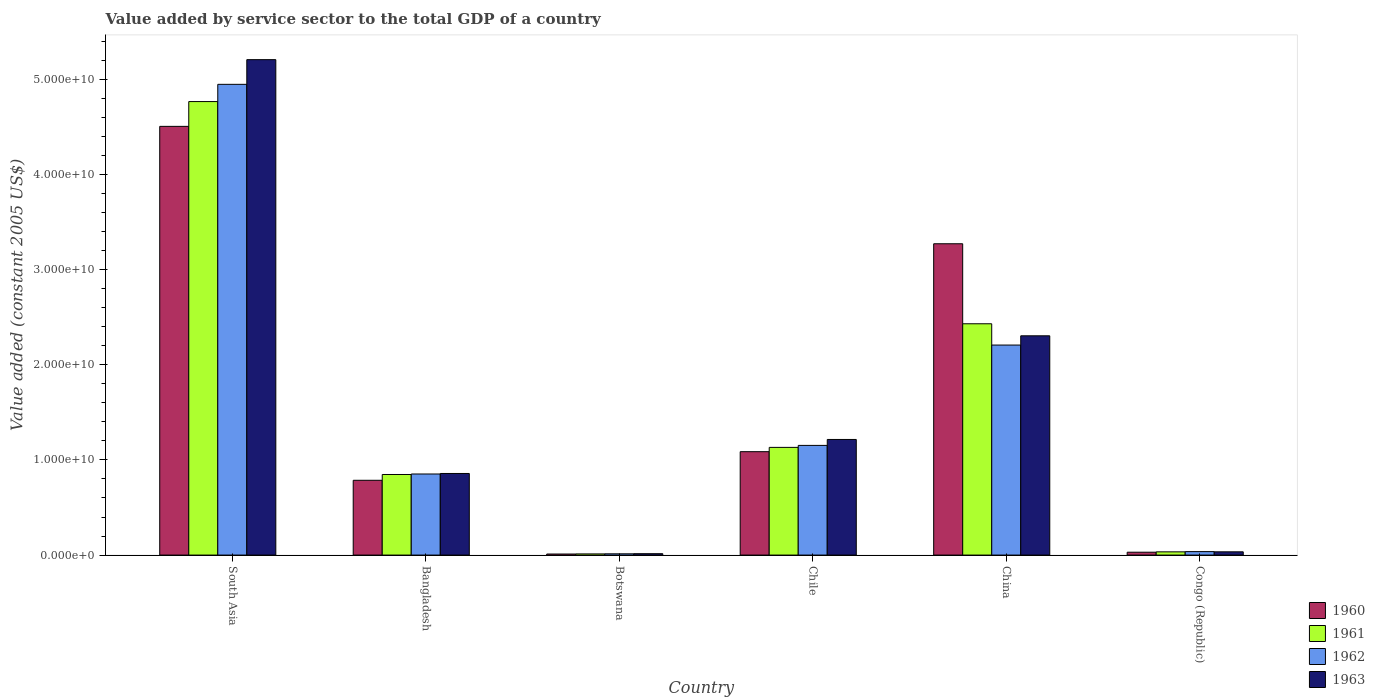How many different coloured bars are there?
Your answer should be compact. 4. How many groups of bars are there?
Offer a very short reply. 6. Are the number of bars per tick equal to the number of legend labels?
Your response must be concise. Yes. Are the number of bars on each tick of the X-axis equal?
Your response must be concise. Yes. How many bars are there on the 2nd tick from the left?
Provide a succinct answer. 4. How many bars are there on the 4th tick from the right?
Your response must be concise. 4. What is the label of the 5th group of bars from the left?
Your answer should be very brief. China. What is the value added by service sector in 1960 in Chile?
Make the answer very short. 1.09e+1. Across all countries, what is the maximum value added by service sector in 1960?
Give a very brief answer. 4.51e+1. Across all countries, what is the minimum value added by service sector in 1962?
Your answer should be compact. 1.32e+08. In which country was the value added by service sector in 1963 minimum?
Keep it short and to the point. Botswana. What is the total value added by service sector in 1961 in the graph?
Your answer should be very brief. 9.22e+1. What is the difference between the value added by service sector in 1961 in Bangladesh and that in Botswana?
Keep it short and to the point. 8.35e+09. What is the difference between the value added by service sector in 1960 in China and the value added by service sector in 1962 in Congo (Republic)?
Give a very brief answer. 3.24e+1. What is the average value added by service sector in 1963 per country?
Keep it short and to the point. 1.61e+1. What is the difference between the value added by service sector of/in 1961 and value added by service sector of/in 1963 in South Asia?
Your answer should be compact. -4.41e+09. What is the ratio of the value added by service sector in 1960 in Chile to that in China?
Your response must be concise. 0.33. Is the value added by service sector in 1961 in Botswana less than that in China?
Ensure brevity in your answer.  Yes. Is the difference between the value added by service sector in 1961 in Botswana and China greater than the difference between the value added by service sector in 1963 in Botswana and China?
Give a very brief answer. No. What is the difference between the highest and the second highest value added by service sector in 1961?
Offer a terse response. -3.63e+1. What is the difference between the highest and the lowest value added by service sector in 1960?
Your answer should be compact. 4.50e+1. In how many countries, is the value added by service sector in 1961 greater than the average value added by service sector in 1961 taken over all countries?
Provide a succinct answer. 2. What does the 2nd bar from the left in Congo (Republic) represents?
Provide a short and direct response. 1961. Is it the case that in every country, the sum of the value added by service sector in 1962 and value added by service sector in 1961 is greater than the value added by service sector in 1960?
Keep it short and to the point. Yes. How many countries are there in the graph?
Your answer should be compact. 6. Does the graph contain any zero values?
Give a very brief answer. No. How many legend labels are there?
Give a very brief answer. 4. How are the legend labels stacked?
Give a very brief answer. Vertical. What is the title of the graph?
Make the answer very short. Value added by service sector to the total GDP of a country. What is the label or title of the X-axis?
Provide a short and direct response. Country. What is the label or title of the Y-axis?
Ensure brevity in your answer.  Value added (constant 2005 US$). What is the Value added (constant 2005 US$) in 1960 in South Asia?
Ensure brevity in your answer.  4.51e+1. What is the Value added (constant 2005 US$) in 1961 in South Asia?
Provide a short and direct response. 4.77e+1. What is the Value added (constant 2005 US$) in 1962 in South Asia?
Keep it short and to the point. 4.95e+1. What is the Value added (constant 2005 US$) of 1963 in South Asia?
Your response must be concise. 5.21e+1. What is the Value added (constant 2005 US$) in 1960 in Bangladesh?
Give a very brief answer. 7.86e+09. What is the Value added (constant 2005 US$) in 1961 in Bangladesh?
Make the answer very short. 8.47e+09. What is the Value added (constant 2005 US$) of 1962 in Bangladesh?
Ensure brevity in your answer.  8.52e+09. What is the Value added (constant 2005 US$) of 1963 in Bangladesh?
Make the answer very short. 8.58e+09. What is the Value added (constant 2005 US$) in 1960 in Botswana?
Make the answer very short. 1.11e+08. What is the Value added (constant 2005 US$) of 1961 in Botswana?
Make the answer very short. 1.22e+08. What is the Value added (constant 2005 US$) of 1962 in Botswana?
Give a very brief answer. 1.32e+08. What is the Value added (constant 2005 US$) of 1963 in Botswana?
Provide a succinct answer. 1.45e+08. What is the Value added (constant 2005 US$) of 1960 in Chile?
Provide a short and direct response. 1.09e+1. What is the Value added (constant 2005 US$) in 1961 in Chile?
Your answer should be very brief. 1.13e+1. What is the Value added (constant 2005 US$) in 1962 in Chile?
Your answer should be very brief. 1.15e+1. What is the Value added (constant 2005 US$) in 1963 in Chile?
Offer a terse response. 1.22e+1. What is the Value added (constant 2005 US$) of 1960 in China?
Offer a very short reply. 3.27e+1. What is the Value added (constant 2005 US$) in 1961 in China?
Provide a succinct answer. 2.43e+1. What is the Value added (constant 2005 US$) in 1962 in China?
Offer a terse response. 2.21e+1. What is the Value added (constant 2005 US$) in 1963 in China?
Ensure brevity in your answer.  2.30e+1. What is the Value added (constant 2005 US$) in 1960 in Congo (Republic)?
Provide a succinct answer. 3.02e+08. What is the Value added (constant 2005 US$) in 1961 in Congo (Republic)?
Your answer should be very brief. 3.39e+08. What is the Value added (constant 2005 US$) of 1962 in Congo (Republic)?
Provide a short and direct response. 3.64e+08. What is the Value added (constant 2005 US$) in 1963 in Congo (Republic)?
Keep it short and to the point. 3.42e+08. Across all countries, what is the maximum Value added (constant 2005 US$) of 1960?
Offer a terse response. 4.51e+1. Across all countries, what is the maximum Value added (constant 2005 US$) of 1961?
Give a very brief answer. 4.77e+1. Across all countries, what is the maximum Value added (constant 2005 US$) of 1962?
Give a very brief answer. 4.95e+1. Across all countries, what is the maximum Value added (constant 2005 US$) in 1963?
Offer a very short reply. 5.21e+1. Across all countries, what is the minimum Value added (constant 2005 US$) in 1960?
Make the answer very short. 1.11e+08. Across all countries, what is the minimum Value added (constant 2005 US$) of 1961?
Make the answer very short. 1.22e+08. Across all countries, what is the minimum Value added (constant 2005 US$) in 1962?
Your response must be concise. 1.32e+08. Across all countries, what is the minimum Value added (constant 2005 US$) in 1963?
Provide a short and direct response. 1.45e+08. What is the total Value added (constant 2005 US$) of 1960 in the graph?
Your answer should be compact. 9.69e+1. What is the total Value added (constant 2005 US$) in 1961 in the graph?
Make the answer very short. 9.22e+1. What is the total Value added (constant 2005 US$) of 1962 in the graph?
Ensure brevity in your answer.  9.21e+1. What is the total Value added (constant 2005 US$) of 1963 in the graph?
Provide a succinct answer. 9.63e+1. What is the difference between the Value added (constant 2005 US$) in 1960 in South Asia and that in Bangladesh?
Your answer should be very brief. 3.72e+1. What is the difference between the Value added (constant 2005 US$) of 1961 in South Asia and that in Bangladesh?
Give a very brief answer. 3.92e+1. What is the difference between the Value added (constant 2005 US$) of 1962 in South Asia and that in Bangladesh?
Your response must be concise. 4.10e+1. What is the difference between the Value added (constant 2005 US$) of 1963 in South Asia and that in Bangladesh?
Your answer should be very brief. 4.35e+1. What is the difference between the Value added (constant 2005 US$) in 1960 in South Asia and that in Botswana?
Give a very brief answer. 4.50e+1. What is the difference between the Value added (constant 2005 US$) in 1961 in South Asia and that in Botswana?
Your response must be concise. 4.75e+1. What is the difference between the Value added (constant 2005 US$) in 1962 in South Asia and that in Botswana?
Your answer should be very brief. 4.93e+1. What is the difference between the Value added (constant 2005 US$) of 1963 in South Asia and that in Botswana?
Provide a short and direct response. 5.19e+1. What is the difference between the Value added (constant 2005 US$) of 1960 in South Asia and that in Chile?
Offer a very short reply. 3.42e+1. What is the difference between the Value added (constant 2005 US$) in 1961 in South Asia and that in Chile?
Provide a succinct answer. 3.63e+1. What is the difference between the Value added (constant 2005 US$) in 1962 in South Asia and that in Chile?
Your answer should be very brief. 3.80e+1. What is the difference between the Value added (constant 2005 US$) of 1963 in South Asia and that in Chile?
Give a very brief answer. 3.99e+1. What is the difference between the Value added (constant 2005 US$) in 1960 in South Asia and that in China?
Offer a terse response. 1.23e+1. What is the difference between the Value added (constant 2005 US$) of 1961 in South Asia and that in China?
Keep it short and to the point. 2.34e+1. What is the difference between the Value added (constant 2005 US$) of 1962 in South Asia and that in China?
Offer a very short reply. 2.74e+1. What is the difference between the Value added (constant 2005 US$) of 1963 in South Asia and that in China?
Provide a succinct answer. 2.90e+1. What is the difference between the Value added (constant 2005 US$) of 1960 in South Asia and that in Congo (Republic)?
Your answer should be very brief. 4.48e+1. What is the difference between the Value added (constant 2005 US$) in 1961 in South Asia and that in Congo (Republic)?
Your answer should be very brief. 4.73e+1. What is the difference between the Value added (constant 2005 US$) in 1962 in South Asia and that in Congo (Republic)?
Keep it short and to the point. 4.91e+1. What is the difference between the Value added (constant 2005 US$) in 1963 in South Asia and that in Congo (Republic)?
Offer a terse response. 5.17e+1. What is the difference between the Value added (constant 2005 US$) in 1960 in Bangladesh and that in Botswana?
Provide a short and direct response. 7.75e+09. What is the difference between the Value added (constant 2005 US$) in 1961 in Bangladesh and that in Botswana?
Provide a succinct answer. 8.35e+09. What is the difference between the Value added (constant 2005 US$) in 1962 in Bangladesh and that in Botswana?
Provide a short and direct response. 8.39e+09. What is the difference between the Value added (constant 2005 US$) in 1963 in Bangladesh and that in Botswana?
Give a very brief answer. 8.43e+09. What is the difference between the Value added (constant 2005 US$) of 1960 in Bangladesh and that in Chile?
Ensure brevity in your answer.  -3.01e+09. What is the difference between the Value added (constant 2005 US$) in 1961 in Bangladesh and that in Chile?
Provide a short and direct response. -2.85e+09. What is the difference between the Value added (constant 2005 US$) of 1962 in Bangladesh and that in Chile?
Make the answer very short. -3.00e+09. What is the difference between the Value added (constant 2005 US$) in 1963 in Bangladesh and that in Chile?
Your answer should be very brief. -3.58e+09. What is the difference between the Value added (constant 2005 US$) of 1960 in Bangladesh and that in China?
Your answer should be very brief. -2.49e+1. What is the difference between the Value added (constant 2005 US$) in 1961 in Bangladesh and that in China?
Give a very brief answer. -1.58e+1. What is the difference between the Value added (constant 2005 US$) in 1962 in Bangladesh and that in China?
Your response must be concise. -1.36e+1. What is the difference between the Value added (constant 2005 US$) in 1963 in Bangladesh and that in China?
Offer a very short reply. -1.45e+1. What is the difference between the Value added (constant 2005 US$) in 1960 in Bangladesh and that in Congo (Republic)?
Your answer should be very brief. 7.56e+09. What is the difference between the Value added (constant 2005 US$) of 1961 in Bangladesh and that in Congo (Republic)?
Provide a succinct answer. 8.13e+09. What is the difference between the Value added (constant 2005 US$) in 1962 in Bangladesh and that in Congo (Republic)?
Give a very brief answer. 8.16e+09. What is the difference between the Value added (constant 2005 US$) of 1963 in Bangladesh and that in Congo (Republic)?
Your answer should be very brief. 8.24e+09. What is the difference between the Value added (constant 2005 US$) of 1960 in Botswana and that in Chile?
Give a very brief answer. -1.08e+1. What is the difference between the Value added (constant 2005 US$) of 1961 in Botswana and that in Chile?
Keep it short and to the point. -1.12e+1. What is the difference between the Value added (constant 2005 US$) in 1962 in Botswana and that in Chile?
Provide a succinct answer. -1.14e+1. What is the difference between the Value added (constant 2005 US$) in 1963 in Botswana and that in Chile?
Keep it short and to the point. -1.20e+1. What is the difference between the Value added (constant 2005 US$) of 1960 in Botswana and that in China?
Offer a very short reply. -3.26e+1. What is the difference between the Value added (constant 2005 US$) in 1961 in Botswana and that in China?
Your answer should be very brief. -2.42e+1. What is the difference between the Value added (constant 2005 US$) of 1962 in Botswana and that in China?
Your response must be concise. -2.19e+1. What is the difference between the Value added (constant 2005 US$) in 1963 in Botswana and that in China?
Your answer should be compact. -2.29e+1. What is the difference between the Value added (constant 2005 US$) in 1960 in Botswana and that in Congo (Republic)?
Offer a terse response. -1.91e+08. What is the difference between the Value added (constant 2005 US$) of 1961 in Botswana and that in Congo (Republic)?
Offer a very short reply. -2.17e+08. What is the difference between the Value added (constant 2005 US$) of 1962 in Botswana and that in Congo (Republic)?
Ensure brevity in your answer.  -2.32e+08. What is the difference between the Value added (constant 2005 US$) of 1963 in Botswana and that in Congo (Republic)?
Make the answer very short. -1.97e+08. What is the difference between the Value added (constant 2005 US$) of 1960 in Chile and that in China?
Offer a terse response. -2.19e+1. What is the difference between the Value added (constant 2005 US$) of 1961 in Chile and that in China?
Offer a very short reply. -1.30e+1. What is the difference between the Value added (constant 2005 US$) of 1962 in Chile and that in China?
Provide a succinct answer. -1.05e+1. What is the difference between the Value added (constant 2005 US$) in 1963 in Chile and that in China?
Your answer should be very brief. -1.09e+1. What is the difference between the Value added (constant 2005 US$) in 1960 in Chile and that in Congo (Republic)?
Provide a succinct answer. 1.06e+1. What is the difference between the Value added (constant 2005 US$) in 1961 in Chile and that in Congo (Republic)?
Offer a terse response. 1.10e+1. What is the difference between the Value added (constant 2005 US$) in 1962 in Chile and that in Congo (Republic)?
Make the answer very short. 1.12e+1. What is the difference between the Value added (constant 2005 US$) of 1963 in Chile and that in Congo (Republic)?
Keep it short and to the point. 1.18e+1. What is the difference between the Value added (constant 2005 US$) in 1960 in China and that in Congo (Republic)?
Your answer should be very brief. 3.24e+1. What is the difference between the Value added (constant 2005 US$) in 1961 in China and that in Congo (Republic)?
Offer a terse response. 2.40e+1. What is the difference between the Value added (constant 2005 US$) of 1962 in China and that in Congo (Republic)?
Offer a very short reply. 2.17e+1. What is the difference between the Value added (constant 2005 US$) in 1963 in China and that in Congo (Republic)?
Keep it short and to the point. 2.27e+1. What is the difference between the Value added (constant 2005 US$) of 1960 in South Asia and the Value added (constant 2005 US$) of 1961 in Bangladesh?
Your answer should be compact. 3.66e+1. What is the difference between the Value added (constant 2005 US$) of 1960 in South Asia and the Value added (constant 2005 US$) of 1962 in Bangladesh?
Keep it short and to the point. 3.65e+1. What is the difference between the Value added (constant 2005 US$) in 1960 in South Asia and the Value added (constant 2005 US$) in 1963 in Bangladesh?
Your response must be concise. 3.65e+1. What is the difference between the Value added (constant 2005 US$) in 1961 in South Asia and the Value added (constant 2005 US$) in 1962 in Bangladesh?
Offer a terse response. 3.91e+1. What is the difference between the Value added (constant 2005 US$) in 1961 in South Asia and the Value added (constant 2005 US$) in 1963 in Bangladesh?
Your response must be concise. 3.91e+1. What is the difference between the Value added (constant 2005 US$) in 1962 in South Asia and the Value added (constant 2005 US$) in 1963 in Bangladesh?
Make the answer very short. 4.09e+1. What is the difference between the Value added (constant 2005 US$) of 1960 in South Asia and the Value added (constant 2005 US$) of 1961 in Botswana?
Provide a succinct answer. 4.49e+1. What is the difference between the Value added (constant 2005 US$) in 1960 in South Asia and the Value added (constant 2005 US$) in 1962 in Botswana?
Provide a succinct answer. 4.49e+1. What is the difference between the Value added (constant 2005 US$) of 1960 in South Asia and the Value added (constant 2005 US$) of 1963 in Botswana?
Provide a short and direct response. 4.49e+1. What is the difference between the Value added (constant 2005 US$) of 1961 in South Asia and the Value added (constant 2005 US$) of 1962 in Botswana?
Offer a terse response. 4.75e+1. What is the difference between the Value added (constant 2005 US$) in 1961 in South Asia and the Value added (constant 2005 US$) in 1963 in Botswana?
Offer a terse response. 4.75e+1. What is the difference between the Value added (constant 2005 US$) of 1962 in South Asia and the Value added (constant 2005 US$) of 1963 in Botswana?
Provide a succinct answer. 4.93e+1. What is the difference between the Value added (constant 2005 US$) of 1960 in South Asia and the Value added (constant 2005 US$) of 1961 in Chile?
Ensure brevity in your answer.  3.37e+1. What is the difference between the Value added (constant 2005 US$) of 1960 in South Asia and the Value added (constant 2005 US$) of 1962 in Chile?
Make the answer very short. 3.35e+1. What is the difference between the Value added (constant 2005 US$) of 1960 in South Asia and the Value added (constant 2005 US$) of 1963 in Chile?
Your answer should be compact. 3.29e+1. What is the difference between the Value added (constant 2005 US$) of 1961 in South Asia and the Value added (constant 2005 US$) of 1962 in Chile?
Make the answer very short. 3.61e+1. What is the difference between the Value added (constant 2005 US$) in 1961 in South Asia and the Value added (constant 2005 US$) in 1963 in Chile?
Keep it short and to the point. 3.55e+1. What is the difference between the Value added (constant 2005 US$) of 1962 in South Asia and the Value added (constant 2005 US$) of 1963 in Chile?
Ensure brevity in your answer.  3.73e+1. What is the difference between the Value added (constant 2005 US$) in 1960 in South Asia and the Value added (constant 2005 US$) in 1961 in China?
Keep it short and to the point. 2.08e+1. What is the difference between the Value added (constant 2005 US$) in 1960 in South Asia and the Value added (constant 2005 US$) in 1962 in China?
Your answer should be very brief. 2.30e+1. What is the difference between the Value added (constant 2005 US$) of 1960 in South Asia and the Value added (constant 2005 US$) of 1963 in China?
Keep it short and to the point. 2.20e+1. What is the difference between the Value added (constant 2005 US$) in 1961 in South Asia and the Value added (constant 2005 US$) in 1962 in China?
Make the answer very short. 2.56e+1. What is the difference between the Value added (constant 2005 US$) of 1961 in South Asia and the Value added (constant 2005 US$) of 1963 in China?
Your response must be concise. 2.46e+1. What is the difference between the Value added (constant 2005 US$) in 1962 in South Asia and the Value added (constant 2005 US$) in 1963 in China?
Offer a terse response. 2.64e+1. What is the difference between the Value added (constant 2005 US$) of 1960 in South Asia and the Value added (constant 2005 US$) of 1961 in Congo (Republic)?
Keep it short and to the point. 4.47e+1. What is the difference between the Value added (constant 2005 US$) in 1960 in South Asia and the Value added (constant 2005 US$) in 1962 in Congo (Republic)?
Your answer should be very brief. 4.47e+1. What is the difference between the Value added (constant 2005 US$) of 1960 in South Asia and the Value added (constant 2005 US$) of 1963 in Congo (Republic)?
Give a very brief answer. 4.47e+1. What is the difference between the Value added (constant 2005 US$) of 1961 in South Asia and the Value added (constant 2005 US$) of 1962 in Congo (Republic)?
Provide a short and direct response. 4.73e+1. What is the difference between the Value added (constant 2005 US$) of 1961 in South Asia and the Value added (constant 2005 US$) of 1963 in Congo (Republic)?
Your answer should be very brief. 4.73e+1. What is the difference between the Value added (constant 2005 US$) in 1962 in South Asia and the Value added (constant 2005 US$) in 1963 in Congo (Republic)?
Make the answer very short. 4.91e+1. What is the difference between the Value added (constant 2005 US$) of 1960 in Bangladesh and the Value added (constant 2005 US$) of 1961 in Botswana?
Ensure brevity in your answer.  7.74e+09. What is the difference between the Value added (constant 2005 US$) of 1960 in Bangladesh and the Value added (constant 2005 US$) of 1962 in Botswana?
Your answer should be compact. 7.73e+09. What is the difference between the Value added (constant 2005 US$) of 1960 in Bangladesh and the Value added (constant 2005 US$) of 1963 in Botswana?
Offer a very short reply. 7.72e+09. What is the difference between the Value added (constant 2005 US$) of 1961 in Bangladesh and the Value added (constant 2005 US$) of 1962 in Botswana?
Give a very brief answer. 8.34e+09. What is the difference between the Value added (constant 2005 US$) of 1961 in Bangladesh and the Value added (constant 2005 US$) of 1963 in Botswana?
Keep it short and to the point. 8.32e+09. What is the difference between the Value added (constant 2005 US$) in 1962 in Bangladesh and the Value added (constant 2005 US$) in 1963 in Botswana?
Ensure brevity in your answer.  8.38e+09. What is the difference between the Value added (constant 2005 US$) in 1960 in Bangladesh and the Value added (constant 2005 US$) in 1961 in Chile?
Provide a short and direct response. -3.46e+09. What is the difference between the Value added (constant 2005 US$) of 1960 in Bangladesh and the Value added (constant 2005 US$) of 1962 in Chile?
Keep it short and to the point. -3.67e+09. What is the difference between the Value added (constant 2005 US$) in 1960 in Bangladesh and the Value added (constant 2005 US$) in 1963 in Chile?
Give a very brief answer. -4.29e+09. What is the difference between the Value added (constant 2005 US$) in 1961 in Bangladesh and the Value added (constant 2005 US$) in 1962 in Chile?
Your answer should be very brief. -3.06e+09. What is the difference between the Value added (constant 2005 US$) of 1961 in Bangladesh and the Value added (constant 2005 US$) of 1963 in Chile?
Give a very brief answer. -3.68e+09. What is the difference between the Value added (constant 2005 US$) in 1962 in Bangladesh and the Value added (constant 2005 US$) in 1963 in Chile?
Offer a very short reply. -3.63e+09. What is the difference between the Value added (constant 2005 US$) of 1960 in Bangladesh and the Value added (constant 2005 US$) of 1961 in China?
Ensure brevity in your answer.  -1.65e+1. What is the difference between the Value added (constant 2005 US$) of 1960 in Bangladesh and the Value added (constant 2005 US$) of 1962 in China?
Give a very brief answer. -1.42e+1. What is the difference between the Value added (constant 2005 US$) of 1960 in Bangladesh and the Value added (constant 2005 US$) of 1963 in China?
Offer a very short reply. -1.52e+1. What is the difference between the Value added (constant 2005 US$) of 1961 in Bangladesh and the Value added (constant 2005 US$) of 1962 in China?
Ensure brevity in your answer.  -1.36e+1. What is the difference between the Value added (constant 2005 US$) of 1961 in Bangladesh and the Value added (constant 2005 US$) of 1963 in China?
Your response must be concise. -1.46e+1. What is the difference between the Value added (constant 2005 US$) of 1962 in Bangladesh and the Value added (constant 2005 US$) of 1963 in China?
Your answer should be compact. -1.45e+1. What is the difference between the Value added (constant 2005 US$) in 1960 in Bangladesh and the Value added (constant 2005 US$) in 1961 in Congo (Republic)?
Your response must be concise. 7.52e+09. What is the difference between the Value added (constant 2005 US$) of 1960 in Bangladesh and the Value added (constant 2005 US$) of 1962 in Congo (Republic)?
Offer a very short reply. 7.50e+09. What is the difference between the Value added (constant 2005 US$) of 1960 in Bangladesh and the Value added (constant 2005 US$) of 1963 in Congo (Republic)?
Your answer should be very brief. 7.52e+09. What is the difference between the Value added (constant 2005 US$) of 1961 in Bangladesh and the Value added (constant 2005 US$) of 1962 in Congo (Republic)?
Keep it short and to the point. 8.11e+09. What is the difference between the Value added (constant 2005 US$) of 1961 in Bangladesh and the Value added (constant 2005 US$) of 1963 in Congo (Republic)?
Your response must be concise. 8.13e+09. What is the difference between the Value added (constant 2005 US$) in 1962 in Bangladesh and the Value added (constant 2005 US$) in 1963 in Congo (Republic)?
Make the answer very short. 8.18e+09. What is the difference between the Value added (constant 2005 US$) of 1960 in Botswana and the Value added (constant 2005 US$) of 1961 in Chile?
Offer a terse response. -1.12e+1. What is the difference between the Value added (constant 2005 US$) in 1960 in Botswana and the Value added (constant 2005 US$) in 1962 in Chile?
Provide a succinct answer. -1.14e+1. What is the difference between the Value added (constant 2005 US$) in 1960 in Botswana and the Value added (constant 2005 US$) in 1963 in Chile?
Keep it short and to the point. -1.20e+1. What is the difference between the Value added (constant 2005 US$) in 1961 in Botswana and the Value added (constant 2005 US$) in 1962 in Chile?
Offer a very short reply. -1.14e+1. What is the difference between the Value added (constant 2005 US$) of 1961 in Botswana and the Value added (constant 2005 US$) of 1963 in Chile?
Offer a terse response. -1.20e+1. What is the difference between the Value added (constant 2005 US$) in 1962 in Botswana and the Value added (constant 2005 US$) in 1963 in Chile?
Provide a short and direct response. -1.20e+1. What is the difference between the Value added (constant 2005 US$) of 1960 in Botswana and the Value added (constant 2005 US$) of 1961 in China?
Your answer should be compact. -2.42e+1. What is the difference between the Value added (constant 2005 US$) in 1960 in Botswana and the Value added (constant 2005 US$) in 1962 in China?
Offer a terse response. -2.20e+1. What is the difference between the Value added (constant 2005 US$) in 1960 in Botswana and the Value added (constant 2005 US$) in 1963 in China?
Offer a terse response. -2.29e+1. What is the difference between the Value added (constant 2005 US$) in 1961 in Botswana and the Value added (constant 2005 US$) in 1962 in China?
Give a very brief answer. -2.20e+1. What is the difference between the Value added (constant 2005 US$) of 1961 in Botswana and the Value added (constant 2005 US$) of 1963 in China?
Give a very brief answer. -2.29e+1. What is the difference between the Value added (constant 2005 US$) of 1962 in Botswana and the Value added (constant 2005 US$) of 1963 in China?
Provide a succinct answer. -2.29e+1. What is the difference between the Value added (constant 2005 US$) in 1960 in Botswana and the Value added (constant 2005 US$) in 1961 in Congo (Republic)?
Offer a very short reply. -2.28e+08. What is the difference between the Value added (constant 2005 US$) in 1960 in Botswana and the Value added (constant 2005 US$) in 1962 in Congo (Republic)?
Offer a terse response. -2.53e+08. What is the difference between the Value added (constant 2005 US$) of 1960 in Botswana and the Value added (constant 2005 US$) of 1963 in Congo (Republic)?
Provide a short and direct response. -2.31e+08. What is the difference between the Value added (constant 2005 US$) in 1961 in Botswana and the Value added (constant 2005 US$) in 1962 in Congo (Republic)?
Your answer should be very brief. -2.42e+08. What is the difference between the Value added (constant 2005 US$) in 1961 in Botswana and the Value added (constant 2005 US$) in 1963 in Congo (Republic)?
Give a very brief answer. -2.20e+08. What is the difference between the Value added (constant 2005 US$) in 1962 in Botswana and the Value added (constant 2005 US$) in 1963 in Congo (Republic)?
Your response must be concise. -2.10e+08. What is the difference between the Value added (constant 2005 US$) of 1960 in Chile and the Value added (constant 2005 US$) of 1961 in China?
Your answer should be very brief. -1.34e+1. What is the difference between the Value added (constant 2005 US$) of 1960 in Chile and the Value added (constant 2005 US$) of 1962 in China?
Provide a succinct answer. -1.12e+1. What is the difference between the Value added (constant 2005 US$) in 1960 in Chile and the Value added (constant 2005 US$) in 1963 in China?
Your answer should be compact. -1.22e+1. What is the difference between the Value added (constant 2005 US$) of 1961 in Chile and the Value added (constant 2005 US$) of 1962 in China?
Offer a terse response. -1.08e+1. What is the difference between the Value added (constant 2005 US$) of 1961 in Chile and the Value added (constant 2005 US$) of 1963 in China?
Provide a succinct answer. -1.17e+1. What is the difference between the Value added (constant 2005 US$) of 1962 in Chile and the Value added (constant 2005 US$) of 1963 in China?
Give a very brief answer. -1.15e+1. What is the difference between the Value added (constant 2005 US$) of 1960 in Chile and the Value added (constant 2005 US$) of 1961 in Congo (Republic)?
Give a very brief answer. 1.05e+1. What is the difference between the Value added (constant 2005 US$) in 1960 in Chile and the Value added (constant 2005 US$) in 1962 in Congo (Republic)?
Provide a succinct answer. 1.05e+1. What is the difference between the Value added (constant 2005 US$) in 1960 in Chile and the Value added (constant 2005 US$) in 1963 in Congo (Republic)?
Make the answer very short. 1.05e+1. What is the difference between the Value added (constant 2005 US$) of 1961 in Chile and the Value added (constant 2005 US$) of 1962 in Congo (Republic)?
Your answer should be very brief. 1.10e+1. What is the difference between the Value added (constant 2005 US$) in 1961 in Chile and the Value added (constant 2005 US$) in 1963 in Congo (Republic)?
Offer a terse response. 1.10e+1. What is the difference between the Value added (constant 2005 US$) in 1962 in Chile and the Value added (constant 2005 US$) in 1963 in Congo (Republic)?
Provide a short and direct response. 1.12e+1. What is the difference between the Value added (constant 2005 US$) in 1960 in China and the Value added (constant 2005 US$) in 1961 in Congo (Republic)?
Provide a succinct answer. 3.24e+1. What is the difference between the Value added (constant 2005 US$) in 1960 in China and the Value added (constant 2005 US$) in 1962 in Congo (Republic)?
Provide a succinct answer. 3.24e+1. What is the difference between the Value added (constant 2005 US$) in 1960 in China and the Value added (constant 2005 US$) in 1963 in Congo (Republic)?
Offer a very short reply. 3.24e+1. What is the difference between the Value added (constant 2005 US$) in 1961 in China and the Value added (constant 2005 US$) in 1962 in Congo (Republic)?
Offer a terse response. 2.39e+1. What is the difference between the Value added (constant 2005 US$) of 1961 in China and the Value added (constant 2005 US$) of 1963 in Congo (Republic)?
Make the answer very short. 2.40e+1. What is the difference between the Value added (constant 2005 US$) in 1962 in China and the Value added (constant 2005 US$) in 1963 in Congo (Republic)?
Provide a short and direct response. 2.17e+1. What is the average Value added (constant 2005 US$) in 1960 per country?
Offer a terse response. 1.62e+1. What is the average Value added (constant 2005 US$) in 1961 per country?
Your response must be concise. 1.54e+1. What is the average Value added (constant 2005 US$) in 1962 per country?
Give a very brief answer. 1.54e+1. What is the average Value added (constant 2005 US$) in 1963 per country?
Your response must be concise. 1.61e+1. What is the difference between the Value added (constant 2005 US$) in 1960 and Value added (constant 2005 US$) in 1961 in South Asia?
Provide a succinct answer. -2.61e+09. What is the difference between the Value added (constant 2005 US$) in 1960 and Value added (constant 2005 US$) in 1962 in South Asia?
Your answer should be compact. -4.42e+09. What is the difference between the Value added (constant 2005 US$) of 1960 and Value added (constant 2005 US$) of 1963 in South Asia?
Your response must be concise. -7.01e+09. What is the difference between the Value added (constant 2005 US$) of 1961 and Value added (constant 2005 US$) of 1962 in South Asia?
Offer a terse response. -1.81e+09. What is the difference between the Value added (constant 2005 US$) of 1961 and Value added (constant 2005 US$) of 1963 in South Asia?
Ensure brevity in your answer.  -4.41e+09. What is the difference between the Value added (constant 2005 US$) in 1962 and Value added (constant 2005 US$) in 1963 in South Asia?
Provide a succinct answer. -2.59e+09. What is the difference between the Value added (constant 2005 US$) in 1960 and Value added (constant 2005 US$) in 1961 in Bangladesh?
Keep it short and to the point. -6.09e+08. What is the difference between the Value added (constant 2005 US$) of 1960 and Value added (constant 2005 US$) of 1962 in Bangladesh?
Offer a terse response. -6.62e+08. What is the difference between the Value added (constant 2005 US$) in 1960 and Value added (constant 2005 US$) in 1963 in Bangladesh?
Offer a terse response. -7.16e+08. What is the difference between the Value added (constant 2005 US$) of 1961 and Value added (constant 2005 US$) of 1962 in Bangladesh?
Keep it short and to the point. -5.33e+07. What is the difference between the Value added (constant 2005 US$) of 1961 and Value added (constant 2005 US$) of 1963 in Bangladesh?
Give a very brief answer. -1.08e+08. What is the difference between the Value added (constant 2005 US$) in 1962 and Value added (constant 2005 US$) in 1963 in Bangladesh?
Offer a very short reply. -5.45e+07. What is the difference between the Value added (constant 2005 US$) in 1960 and Value added (constant 2005 US$) in 1961 in Botswana?
Give a very brief answer. -1.12e+07. What is the difference between the Value added (constant 2005 US$) in 1960 and Value added (constant 2005 US$) in 1962 in Botswana?
Give a very brief answer. -2.17e+07. What is the difference between the Value added (constant 2005 US$) in 1960 and Value added (constant 2005 US$) in 1963 in Botswana?
Provide a succinct answer. -3.45e+07. What is the difference between the Value added (constant 2005 US$) of 1961 and Value added (constant 2005 US$) of 1962 in Botswana?
Your response must be concise. -1.05e+07. What is the difference between the Value added (constant 2005 US$) of 1961 and Value added (constant 2005 US$) of 1963 in Botswana?
Provide a short and direct response. -2.33e+07. What is the difference between the Value added (constant 2005 US$) in 1962 and Value added (constant 2005 US$) in 1963 in Botswana?
Your answer should be very brief. -1.28e+07. What is the difference between the Value added (constant 2005 US$) of 1960 and Value added (constant 2005 US$) of 1961 in Chile?
Make the answer very short. -4.53e+08. What is the difference between the Value added (constant 2005 US$) of 1960 and Value added (constant 2005 US$) of 1962 in Chile?
Provide a succinct answer. -6.60e+08. What is the difference between the Value added (constant 2005 US$) of 1960 and Value added (constant 2005 US$) of 1963 in Chile?
Make the answer very short. -1.29e+09. What is the difference between the Value added (constant 2005 US$) in 1961 and Value added (constant 2005 US$) in 1962 in Chile?
Provide a short and direct response. -2.07e+08. What is the difference between the Value added (constant 2005 US$) in 1961 and Value added (constant 2005 US$) in 1963 in Chile?
Make the answer very short. -8.32e+08. What is the difference between the Value added (constant 2005 US$) in 1962 and Value added (constant 2005 US$) in 1963 in Chile?
Ensure brevity in your answer.  -6.25e+08. What is the difference between the Value added (constant 2005 US$) of 1960 and Value added (constant 2005 US$) of 1961 in China?
Offer a very short reply. 8.41e+09. What is the difference between the Value added (constant 2005 US$) of 1960 and Value added (constant 2005 US$) of 1962 in China?
Offer a very short reply. 1.06e+1. What is the difference between the Value added (constant 2005 US$) of 1960 and Value added (constant 2005 US$) of 1963 in China?
Offer a very short reply. 9.68e+09. What is the difference between the Value added (constant 2005 US$) of 1961 and Value added (constant 2005 US$) of 1962 in China?
Make the answer very short. 2.24e+09. What is the difference between the Value added (constant 2005 US$) of 1961 and Value added (constant 2005 US$) of 1963 in China?
Give a very brief answer. 1.27e+09. What is the difference between the Value added (constant 2005 US$) of 1962 and Value added (constant 2005 US$) of 1963 in China?
Your response must be concise. -9.71e+08. What is the difference between the Value added (constant 2005 US$) of 1960 and Value added (constant 2005 US$) of 1961 in Congo (Republic)?
Provide a succinct answer. -3.74e+07. What is the difference between the Value added (constant 2005 US$) in 1960 and Value added (constant 2005 US$) in 1962 in Congo (Republic)?
Ensure brevity in your answer.  -6.23e+07. What is the difference between the Value added (constant 2005 US$) of 1960 and Value added (constant 2005 US$) of 1963 in Congo (Republic)?
Your answer should be very brief. -4.05e+07. What is the difference between the Value added (constant 2005 US$) in 1961 and Value added (constant 2005 US$) in 1962 in Congo (Republic)?
Offer a terse response. -2.49e+07. What is the difference between the Value added (constant 2005 US$) of 1961 and Value added (constant 2005 US$) of 1963 in Congo (Republic)?
Make the answer very short. -3.09e+06. What is the difference between the Value added (constant 2005 US$) in 1962 and Value added (constant 2005 US$) in 1963 in Congo (Republic)?
Give a very brief answer. 2.18e+07. What is the ratio of the Value added (constant 2005 US$) in 1960 in South Asia to that in Bangladesh?
Provide a succinct answer. 5.73. What is the ratio of the Value added (constant 2005 US$) in 1961 in South Asia to that in Bangladesh?
Make the answer very short. 5.63. What is the ratio of the Value added (constant 2005 US$) in 1962 in South Asia to that in Bangladesh?
Ensure brevity in your answer.  5.81. What is the ratio of the Value added (constant 2005 US$) in 1963 in South Asia to that in Bangladesh?
Your answer should be very brief. 6.07. What is the ratio of the Value added (constant 2005 US$) of 1960 in South Asia to that in Botswana?
Provide a succinct answer. 407.52. What is the ratio of the Value added (constant 2005 US$) in 1961 in South Asia to that in Botswana?
Give a very brief answer. 391.45. What is the ratio of the Value added (constant 2005 US$) in 1962 in South Asia to that in Botswana?
Offer a terse response. 374.08. What is the ratio of the Value added (constant 2005 US$) in 1963 in South Asia to that in Botswana?
Keep it short and to the point. 358.96. What is the ratio of the Value added (constant 2005 US$) of 1960 in South Asia to that in Chile?
Your response must be concise. 4.15. What is the ratio of the Value added (constant 2005 US$) of 1961 in South Asia to that in Chile?
Provide a short and direct response. 4.21. What is the ratio of the Value added (constant 2005 US$) of 1962 in South Asia to that in Chile?
Keep it short and to the point. 4.29. What is the ratio of the Value added (constant 2005 US$) in 1963 in South Asia to that in Chile?
Offer a terse response. 4.29. What is the ratio of the Value added (constant 2005 US$) in 1960 in South Asia to that in China?
Your answer should be very brief. 1.38. What is the ratio of the Value added (constant 2005 US$) in 1961 in South Asia to that in China?
Keep it short and to the point. 1.96. What is the ratio of the Value added (constant 2005 US$) in 1962 in South Asia to that in China?
Your answer should be compact. 2.24. What is the ratio of the Value added (constant 2005 US$) in 1963 in South Asia to that in China?
Ensure brevity in your answer.  2.26. What is the ratio of the Value added (constant 2005 US$) of 1960 in South Asia to that in Congo (Republic)?
Your answer should be compact. 149.43. What is the ratio of the Value added (constant 2005 US$) of 1961 in South Asia to that in Congo (Republic)?
Offer a terse response. 140.64. What is the ratio of the Value added (constant 2005 US$) of 1962 in South Asia to that in Congo (Republic)?
Ensure brevity in your answer.  135.99. What is the ratio of the Value added (constant 2005 US$) in 1963 in South Asia to that in Congo (Republic)?
Provide a short and direct response. 152.26. What is the ratio of the Value added (constant 2005 US$) in 1960 in Bangladesh to that in Botswana?
Ensure brevity in your answer.  71.09. What is the ratio of the Value added (constant 2005 US$) in 1961 in Bangladesh to that in Botswana?
Provide a succinct answer. 69.55. What is the ratio of the Value added (constant 2005 US$) in 1962 in Bangladesh to that in Botswana?
Give a very brief answer. 64.43. What is the ratio of the Value added (constant 2005 US$) of 1963 in Bangladesh to that in Botswana?
Your response must be concise. 59.12. What is the ratio of the Value added (constant 2005 US$) in 1960 in Bangladesh to that in Chile?
Provide a succinct answer. 0.72. What is the ratio of the Value added (constant 2005 US$) of 1961 in Bangladesh to that in Chile?
Ensure brevity in your answer.  0.75. What is the ratio of the Value added (constant 2005 US$) in 1962 in Bangladesh to that in Chile?
Make the answer very short. 0.74. What is the ratio of the Value added (constant 2005 US$) of 1963 in Bangladesh to that in Chile?
Provide a short and direct response. 0.71. What is the ratio of the Value added (constant 2005 US$) in 1960 in Bangladesh to that in China?
Ensure brevity in your answer.  0.24. What is the ratio of the Value added (constant 2005 US$) of 1961 in Bangladesh to that in China?
Offer a very short reply. 0.35. What is the ratio of the Value added (constant 2005 US$) of 1962 in Bangladesh to that in China?
Your response must be concise. 0.39. What is the ratio of the Value added (constant 2005 US$) of 1963 in Bangladesh to that in China?
Make the answer very short. 0.37. What is the ratio of the Value added (constant 2005 US$) of 1960 in Bangladesh to that in Congo (Republic)?
Provide a short and direct response. 26.07. What is the ratio of the Value added (constant 2005 US$) of 1961 in Bangladesh to that in Congo (Republic)?
Your response must be concise. 24.99. What is the ratio of the Value added (constant 2005 US$) in 1962 in Bangladesh to that in Congo (Republic)?
Your answer should be compact. 23.42. What is the ratio of the Value added (constant 2005 US$) of 1963 in Bangladesh to that in Congo (Republic)?
Make the answer very short. 25.08. What is the ratio of the Value added (constant 2005 US$) of 1960 in Botswana to that in Chile?
Offer a terse response. 0.01. What is the ratio of the Value added (constant 2005 US$) in 1961 in Botswana to that in Chile?
Provide a succinct answer. 0.01. What is the ratio of the Value added (constant 2005 US$) of 1962 in Botswana to that in Chile?
Provide a short and direct response. 0.01. What is the ratio of the Value added (constant 2005 US$) of 1963 in Botswana to that in Chile?
Your response must be concise. 0.01. What is the ratio of the Value added (constant 2005 US$) in 1960 in Botswana to that in China?
Give a very brief answer. 0. What is the ratio of the Value added (constant 2005 US$) of 1961 in Botswana to that in China?
Your answer should be very brief. 0.01. What is the ratio of the Value added (constant 2005 US$) in 1962 in Botswana to that in China?
Offer a terse response. 0.01. What is the ratio of the Value added (constant 2005 US$) in 1963 in Botswana to that in China?
Offer a very short reply. 0.01. What is the ratio of the Value added (constant 2005 US$) in 1960 in Botswana to that in Congo (Republic)?
Make the answer very short. 0.37. What is the ratio of the Value added (constant 2005 US$) of 1961 in Botswana to that in Congo (Republic)?
Offer a very short reply. 0.36. What is the ratio of the Value added (constant 2005 US$) in 1962 in Botswana to that in Congo (Republic)?
Keep it short and to the point. 0.36. What is the ratio of the Value added (constant 2005 US$) of 1963 in Botswana to that in Congo (Republic)?
Your response must be concise. 0.42. What is the ratio of the Value added (constant 2005 US$) in 1960 in Chile to that in China?
Your response must be concise. 0.33. What is the ratio of the Value added (constant 2005 US$) of 1961 in Chile to that in China?
Provide a short and direct response. 0.47. What is the ratio of the Value added (constant 2005 US$) of 1962 in Chile to that in China?
Make the answer very short. 0.52. What is the ratio of the Value added (constant 2005 US$) of 1963 in Chile to that in China?
Keep it short and to the point. 0.53. What is the ratio of the Value added (constant 2005 US$) of 1960 in Chile to that in Congo (Republic)?
Provide a succinct answer. 36.04. What is the ratio of the Value added (constant 2005 US$) in 1961 in Chile to that in Congo (Republic)?
Give a very brief answer. 33.4. What is the ratio of the Value added (constant 2005 US$) of 1962 in Chile to that in Congo (Republic)?
Provide a short and direct response. 31.68. What is the ratio of the Value added (constant 2005 US$) in 1963 in Chile to that in Congo (Republic)?
Your response must be concise. 35.53. What is the ratio of the Value added (constant 2005 US$) of 1960 in China to that in Congo (Republic)?
Provide a short and direct response. 108.51. What is the ratio of the Value added (constant 2005 US$) of 1961 in China to that in Congo (Republic)?
Provide a succinct answer. 71.73. What is the ratio of the Value added (constant 2005 US$) of 1962 in China to that in Congo (Republic)?
Make the answer very short. 60.67. What is the ratio of the Value added (constant 2005 US$) of 1963 in China to that in Congo (Republic)?
Keep it short and to the point. 67.39. What is the difference between the highest and the second highest Value added (constant 2005 US$) in 1960?
Keep it short and to the point. 1.23e+1. What is the difference between the highest and the second highest Value added (constant 2005 US$) in 1961?
Make the answer very short. 2.34e+1. What is the difference between the highest and the second highest Value added (constant 2005 US$) in 1962?
Keep it short and to the point. 2.74e+1. What is the difference between the highest and the second highest Value added (constant 2005 US$) in 1963?
Your answer should be compact. 2.90e+1. What is the difference between the highest and the lowest Value added (constant 2005 US$) in 1960?
Provide a short and direct response. 4.50e+1. What is the difference between the highest and the lowest Value added (constant 2005 US$) in 1961?
Your answer should be compact. 4.75e+1. What is the difference between the highest and the lowest Value added (constant 2005 US$) of 1962?
Provide a succinct answer. 4.93e+1. What is the difference between the highest and the lowest Value added (constant 2005 US$) in 1963?
Your response must be concise. 5.19e+1. 